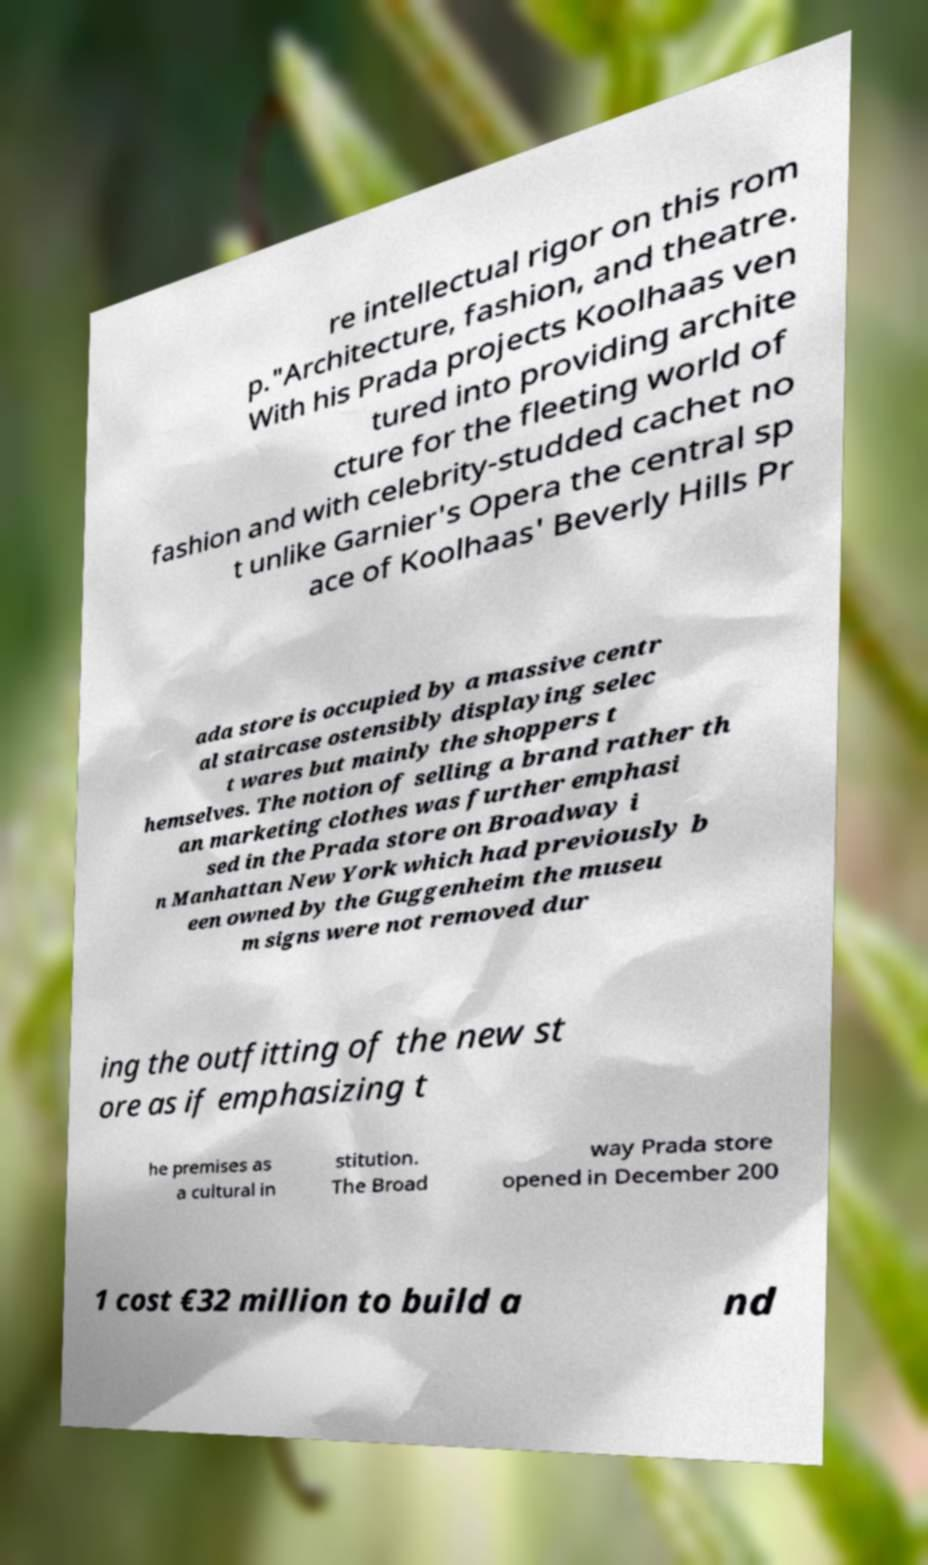What messages or text are displayed in this image? I need them in a readable, typed format. re intellectual rigor on this rom p."Architecture, fashion, and theatre. With his Prada projects Koolhaas ven tured into providing archite cture for the fleeting world of fashion and with celebrity-studded cachet no t unlike Garnier's Opera the central sp ace of Koolhaas' Beverly Hills Pr ada store is occupied by a massive centr al staircase ostensibly displaying selec t wares but mainly the shoppers t hemselves. The notion of selling a brand rather th an marketing clothes was further emphasi sed in the Prada store on Broadway i n Manhattan New York which had previously b een owned by the Guggenheim the museu m signs were not removed dur ing the outfitting of the new st ore as if emphasizing t he premises as a cultural in stitution. The Broad way Prada store opened in December 200 1 cost €32 million to build a nd 